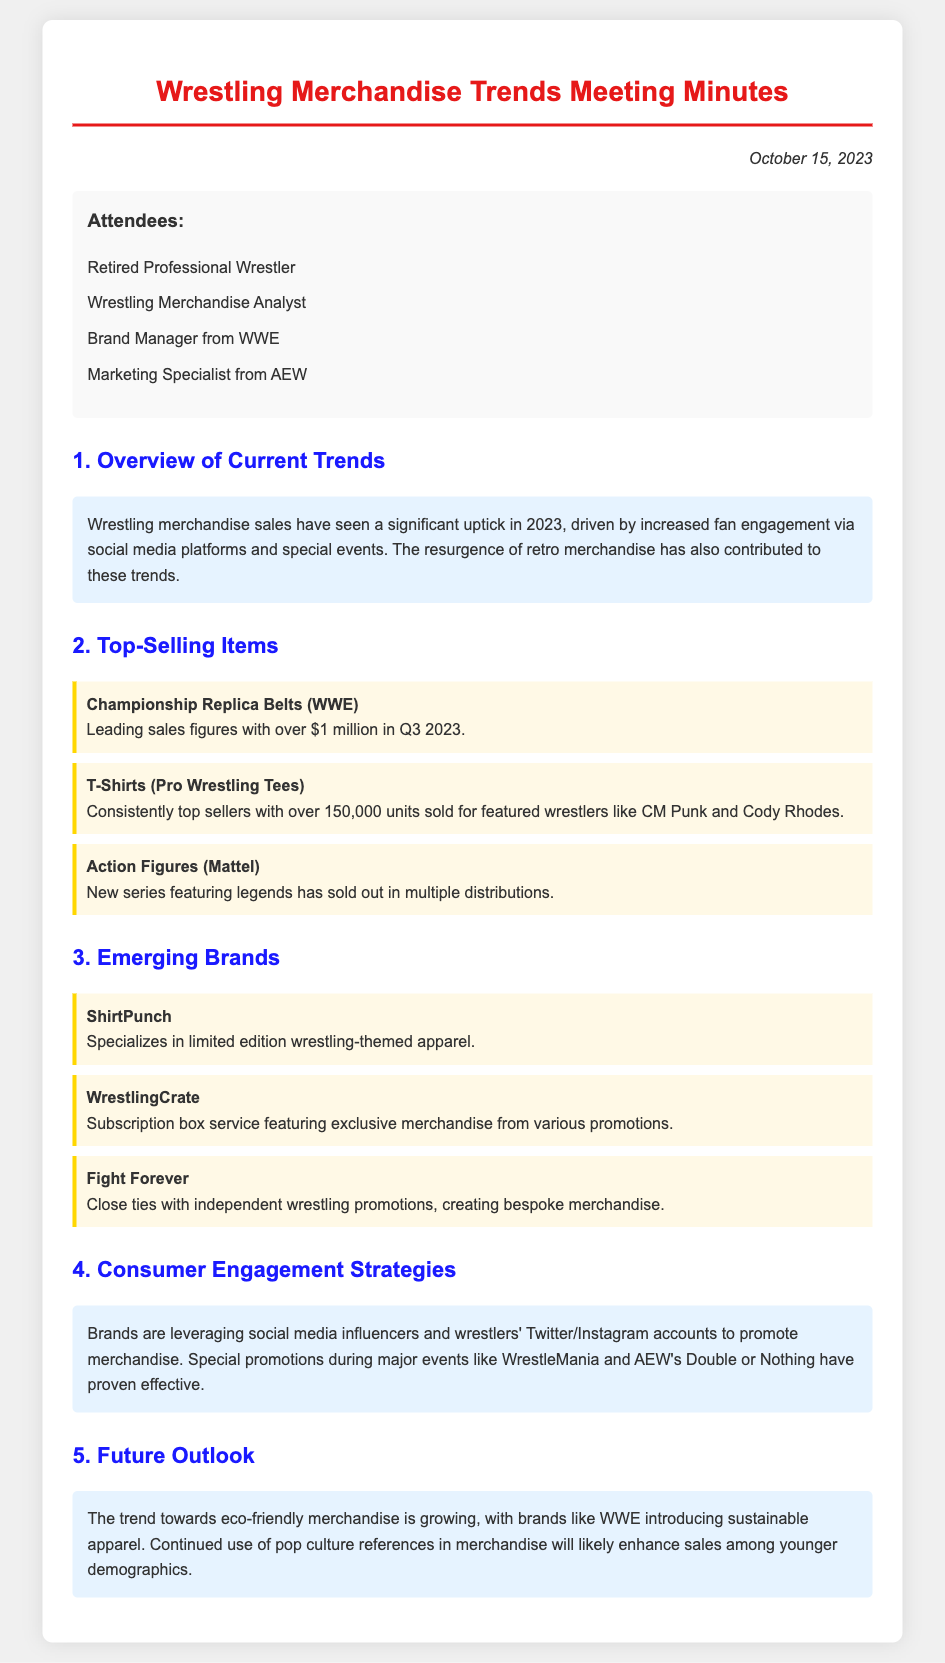what is the date of the meeting? The date of the meeting is mentioned at the top of the document.
Answer: October 15, 2023 who is listed as a top-selling item? The document highlights various top-selling items under specific categories.
Answer: Championship Replica Belts (WWE) how many units of T-Shirts have been sold? The document specifies the number of units sold for T-Shirts.
Answer: 150,000 units which emerging brand specializes in limited edition apparel? The document lists emerging brands and their specialties.
Answer: ShirtPunch what is the primary factor driving merchandise sales increase in 2023? The document discusses trends and influencing factors on sales.
Answer: Increased fan engagement via social media platforms what type of strategies are brands using for consumer engagement? The document describes strategies brands leverage for engaging consumers.
Answer: Social media influencers what is the trend concerning eco-friendly merchandise? The document mentions a growing trend related to merchandise sustainability.
Answer: Growing who attended the meeting? The document lists attendees participating in the meeting.
Answer: Retired Professional Wrestler, Wrestling Merchandise Analyst, Brand Manager from WWE, Marketing Specialist from AEW how much revenue did Championship Replica Belts generate in Q3 2023? The document provides specific sales figures for Championship Replica Belts.
Answer: Over $1 million 